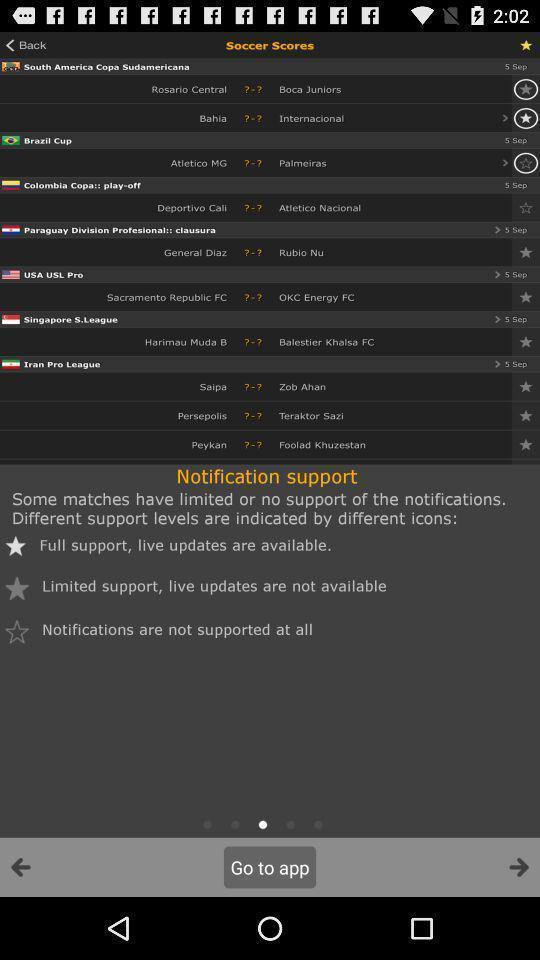Tell me about the visual elements in this screen capture. Page of a sports app with scores. 